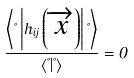Convert formula to latex. <formula><loc_0><loc_0><loc_500><loc_500>\frac { \left \langle \Psi \left | h _ { i j } \left ( \overrightarrow { x } \right ) \right | \Psi \right \rangle } { \left \langle \Psi | \Psi \right \rangle } = 0</formula> 